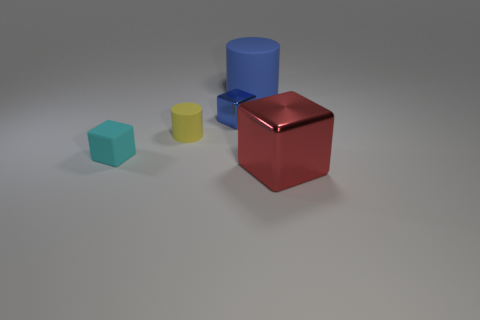Add 1 gray shiny balls. How many objects exist? 6 Subtract all cubes. How many objects are left? 2 Subtract 0 cyan balls. How many objects are left? 5 Subtract all gray matte balls. Subtract all blue cylinders. How many objects are left? 4 Add 2 blue things. How many blue things are left? 4 Add 4 tiny objects. How many tiny objects exist? 7 